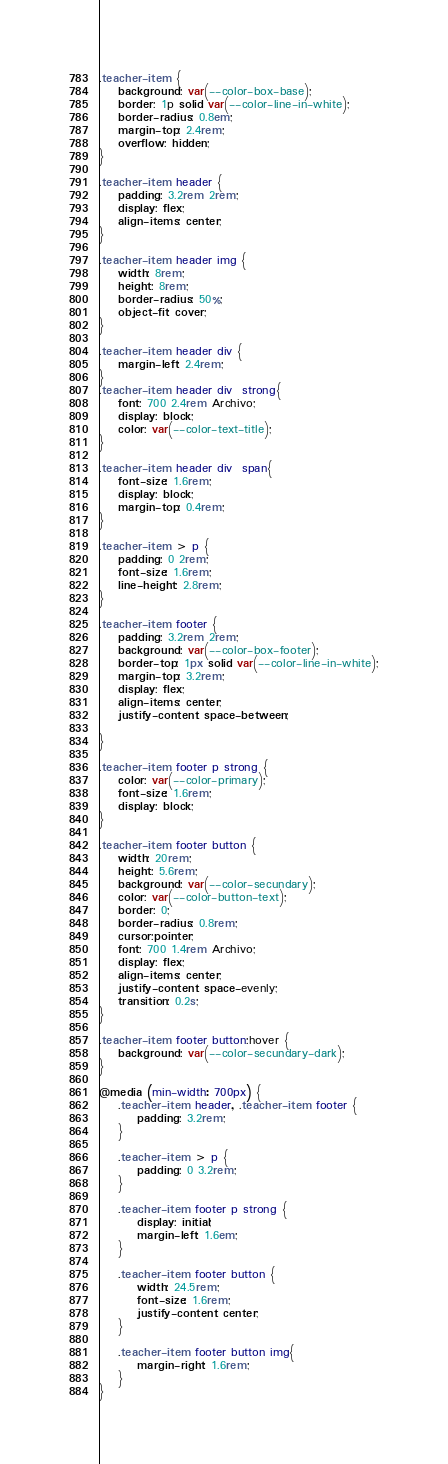<code> <loc_0><loc_0><loc_500><loc_500><_CSS_>.teacher-item {
    background: var(--color-box-base);
    border: 1p solid var(--color-line-in-white);
    border-radius: 0.8em;
    margin-top: 2.4rem;
    overflow: hidden;
}

.teacher-item header {
    padding: 3.2rem 2rem;
    display: flex;
    align-items: center;
}

.teacher-item header img {
    width: 8rem;
    height: 8rem;
    border-radius: 50%;
    object-fit: cover;
}

.teacher-item header div {
    margin-left: 2.4rem;
}
.teacher-item header div  strong{
    font: 700 2.4rem Archivo;
    display: block;
    color: var(--color-text-title);
}

.teacher-item header div  span{
    font-size: 1.6rem;
    display: block;
    margin-top: 0.4rem;
}

.teacher-item > p {
    padding: 0 2rem;
    font-size: 1.6rem;
    line-height: 2.8rem;
}

.teacher-item footer {
    padding: 3.2rem 2rem;
    background: var(--color-box-footer);
    border-top: 1px solid var(--color-line-in-white);
    margin-top: 3.2rem;
    display: flex;
    align-items: center;
    justify-content: space-between;

}

.teacher-item footer p strong {
    color: var(--color-primary);
    font-size: 1.6rem;
    display: block;
}

.teacher-item footer button {
    width: 20rem;
    height: 5.6rem;
    background: var(--color-secundary);
    color: var(--color-button-text);
    border: 0;
    border-radius: 0.8rem;
    cursor:pointer;
    font: 700 1.4rem Archivo;
    display: flex;
    align-items: center;
    justify-content: space-evenly;
    transition: 0.2s;
}

.teacher-item footer button:hover {
    background: var(--color-secundary-dark);
}

@media (min-width: 700px) {
    .teacher-item header, .teacher-item footer {
        padding: 3.2rem;
    }

    .teacher-item > p {
        padding: 0 3.2rem;
    }

    .teacher-item footer p strong {
        display: initial;
        margin-left: 1.6em;
    }

    .teacher-item footer button {
        width: 24.5rem;
        font-size: 1.6rem;
        justify-content: center;
    }

    .teacher-item footer button img{
        margin-right: 1.6rem;
    }
}
</code> 